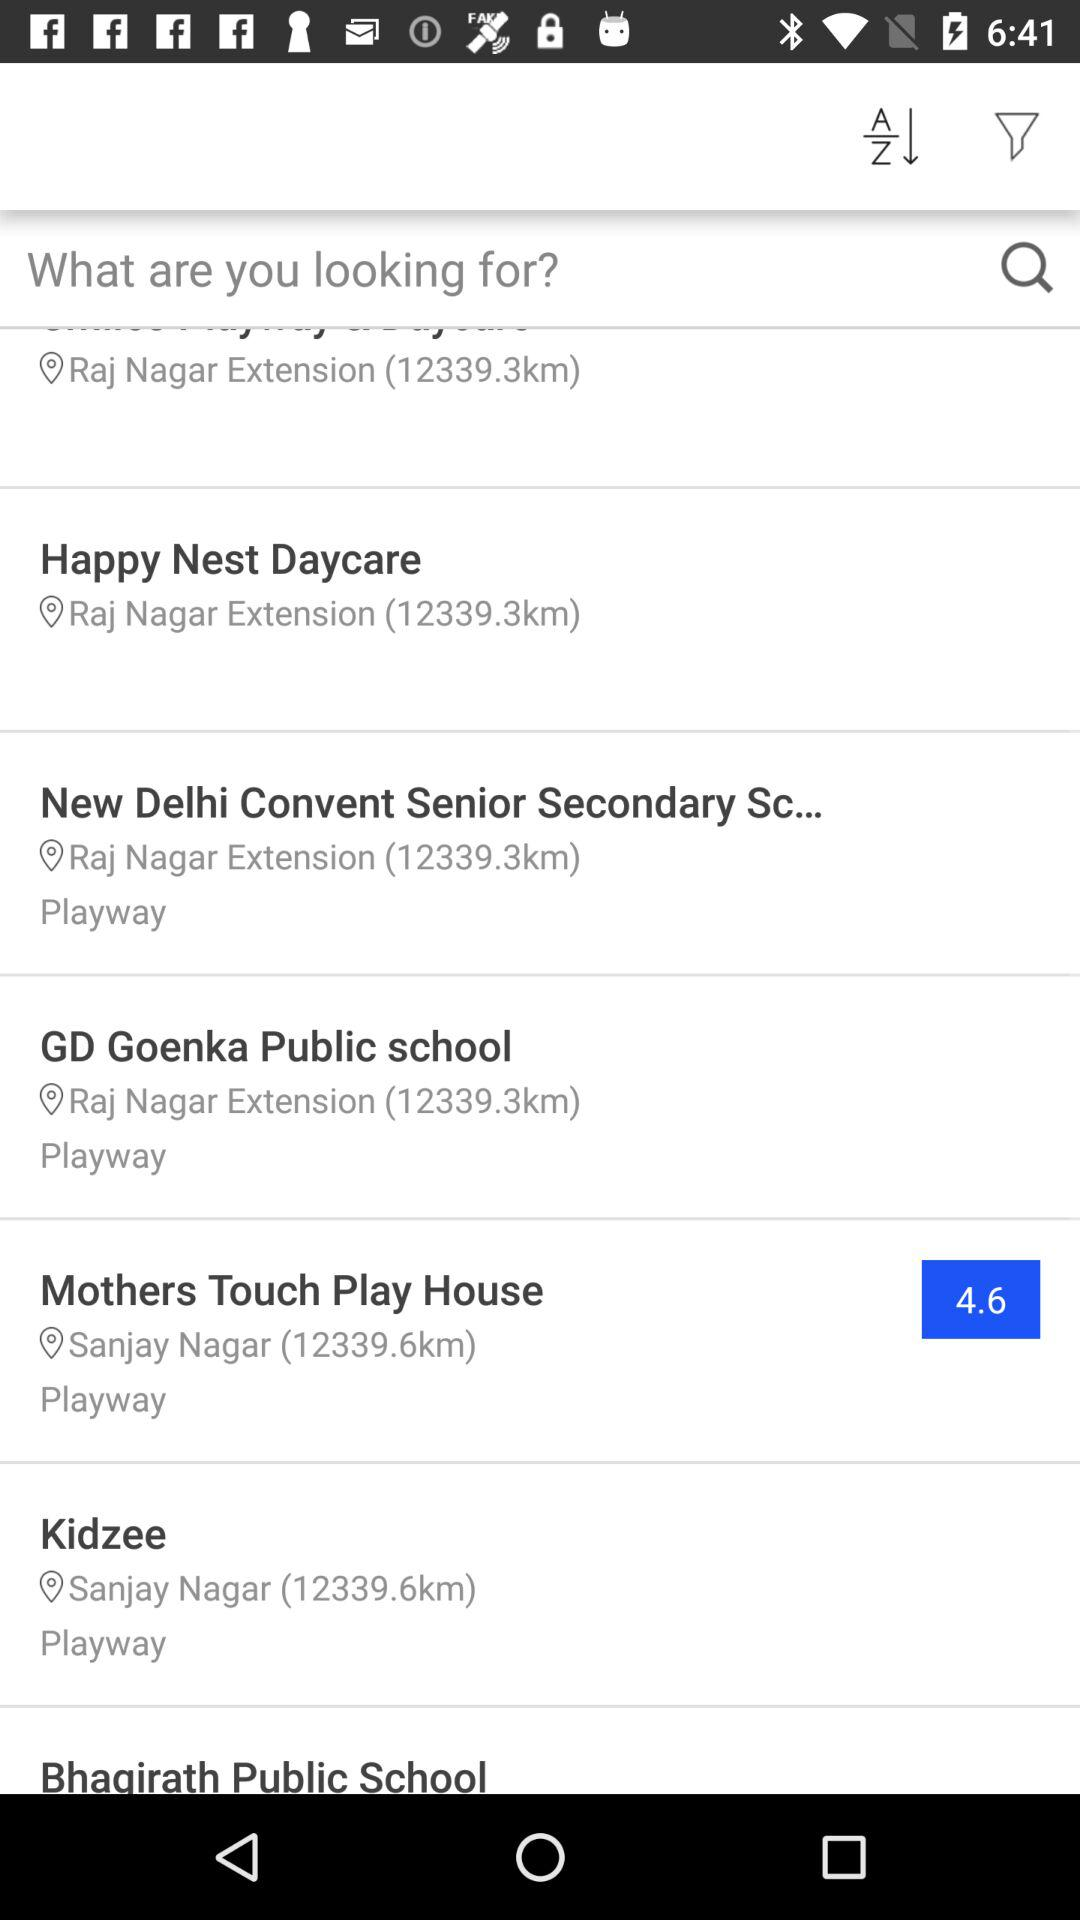How far is GD Goenka public school from my location? GD Goenka public school is 12339.6km away from my location. 